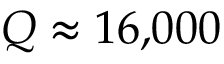<formula> <loc_0><loc_0><loc_500><loc_500>Q \approx 1 6 { , } 0 0 0</formula> 